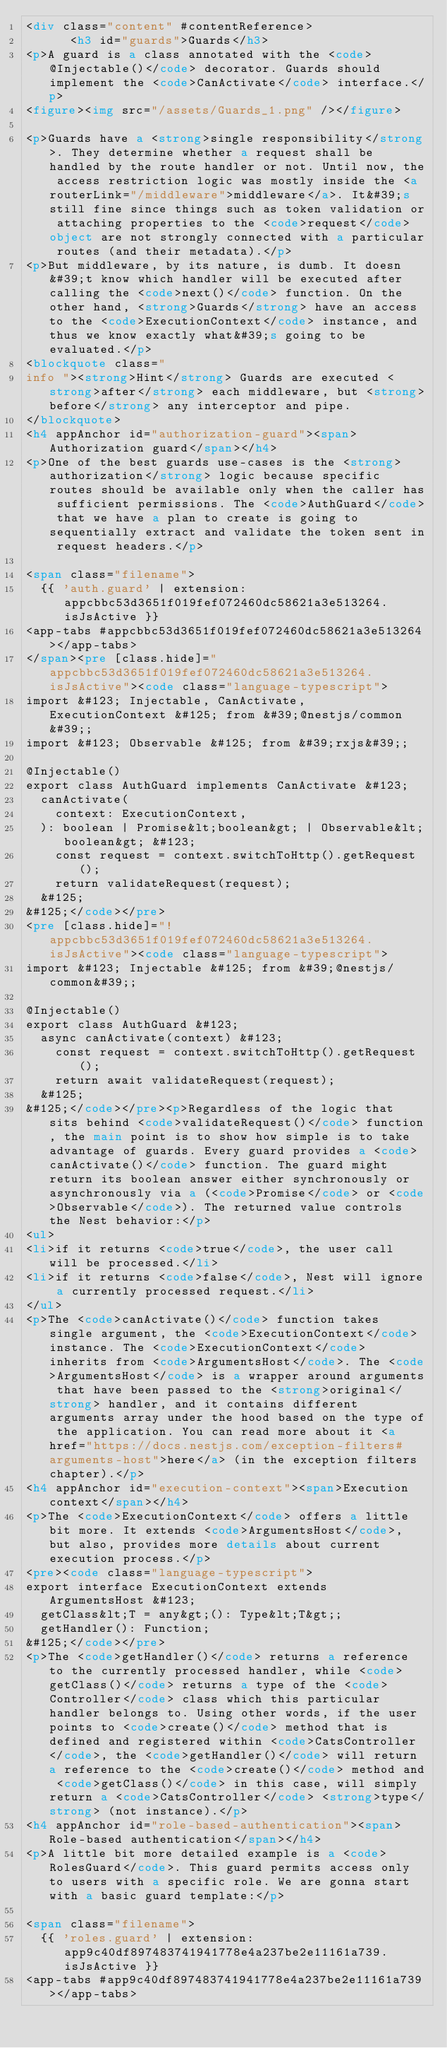Convert code to text. <code><loc_0><loc_0><loc_500><loc_500><_HTML_><div class="content" #contentReference>
      <h3 id="guards">Guards</h3>
<p>A guard is a class annotated with the <code>@Injectable()</code> decorator. Guards should implement the <code>CanActivate</code> interface.</p>
<figure><img src="/assets/Guards_1.png" /></figure>

<p>Guards have a <strong>single responsibility</strong>. They determine whether a request shall be handled by the route handler or not. Until now, the access restriction logic was mostly inside the <a routerLink="/middleware">middleware</a>. It&#39;s still fine since things such as token validation or attaching properties to the <code>request</code> object are not strongly connected with a particular routes (and their metadata).</p>
<p>But middleware, by its nature, is dumb. It doesn&#39;t know which handler will be executed after calling the <code>next()</code> function. On the other hand, <strong>Guards</strong> have an access to the <code>ExecutionContext</code> instance, and thus we know exactly what&#39;s going to be evaluated.</p>
<blockquote class="
info "><strong>Hint</strong> Guards are executed <strong>after</strong> each middleware, but <strong>before</strong> any interceptor and pipe.
</blockquote>
<h4 appAnchor id="authorization-guard"><span>Authorization guard</span></h4>
<p>One of the best guards use-cases is the <strong>authorization</strong> logic because specific routes should be available only when the caller has sufficient permissions. The <code>AuthGuard</code> that we have a plan to create is going to sequentially extract and validate the token sent in request headers.</p>

<span class="filename">
  {{ 'auth.guard' | extension: appcbbc53d3651f019fef072460dc58621a3e513264.isJsActive }}
<app-tabs #appcbbc53d3651f019fef072460dc58621a3e513264></app-tabs>
</span><pre [class.hide]="appcbbc53d3651f019fef072460dc58621a3e513264.isJsActive"><code class="language-typescript">
import &#123; Injectable, CanActivate, ExecutionContext &#125; from &#39;@nestjs/common&#39;;
import &#123; Observable &#125; from &#39;rxjs&#39;;

@Injectable()
export class AuthGuard implements CanActivate &#123;
  canActivate(
    context: ExecutionContext,
  ): boolean | Promise&lt;boolean&gt; | Observable&lt;boolean&gt; &#123;
    const request = context.switchToHttp().getRequest();
    return validateRequest(request);
  &#125;
&#125;</code></pre>
<pre [class.hide]="!appcbbc53d3651f019fef072460dc58621a3e513264.isJsActive"><code class="language-typescript">
import &#123; Injectable &#125; from &#39;@nestjs/common&#39;;

@Injectable()
export class AuthGuard &#123;
  async canActivate(context) &#123;
    const request = context.switchToHttp().getRequest();
    return await validateRequest(request);
  &#125;
&#125;</code></pre><p>Regardless of the logic that sits behind <code>validateRequest()</code> function, the main point is to show how simple is to take advantage of guards. Every guard provides a <code>canActivate()</code> function. The guard might return its boolean answer either synchronously or asynchronously via a (<code>Promise</code> or <code>Observable</code>). The returned value controls the Nest behavior:</p>
<ul>
<li>if it returns <code>true</code>, the user call will be processed.</li>
<li>if it returns <code>false</code>, Nest will ignore a currently processed request.</li>
</ul>
<p>The <code>canActivate()</code> function takes single argument, the <code>ExecutionContext</code> instance. The <code>ExecutionContext</code> inherits from <code>ArgumentsHost</code>. The <code>ArgumentsHost</code> is a wrapper around arguments that have been passed to the <strong>original</strong> handler, and it contains different arguments array under the hood based on the type of the application. You can read more about it <a href="https://docs.nestjs.com/exception-filters#arguments-host">here</a> (in the exception filters chapter).</p>
<h4 appAnchor id="execution-context"><span>Execution context</span></h4>
<p>The <code>ExecutionContext</code> offers a little bit more. It extends <code>ArgumentsHost</code>, but also, provides more details about current execution process.</p>
<pre><code class="language-typescript">
export interface ExecutionContext extends ArgumentsHost &#123;
  getClass&lt;T = any&gt;(): Type&lt;T&gt;;
  getHandler(): Function;
&#125;</code></pre>
<p>The <code>getHandler()</code> returns a reference to the currently processed handler, while <code>getClass()</code> returns a type of the <code>Controller</code> class which this particular handler belongs to. Using other words, if the user points to <code>create()</code> method that is defined and registered within <code>CatsController</code>, the <code>getHandler()</code> will return a reference to the <code>create()</code> method and <code>getClass()</code> in this case, will simply return a <code>CatsController</code> <strong>type</strong> (not instance).</p>
<h4 appAnchor id="role-based-authentication"><span>Role-based authentication</span></h4>
<p>A little bit more detailed example is a <code>RolesGuard</code>. This guard permits access only to users with a specific role. We are gonna start with a basic guard template:</p>

<span class="filename">
  {{ 'roles.guard' | extension: app9c40df897483741941778e4a237be2e11161a739.isJsActive }}
<app-tabs #app9c40df897483741941778e4a237be2e11161a739></app-tabs></code> 